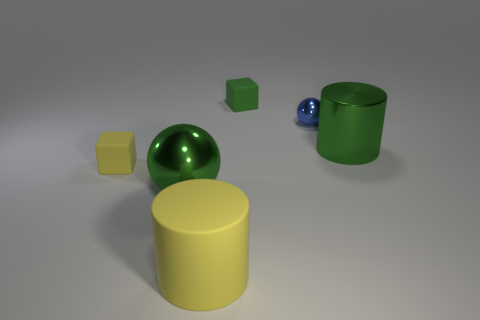Subtract all green balls. How many balls are left? 1 Add 3 big brown metallic cubes. How many objects exist? 9 Subtract all spheres. How many objects are left? 4 Add 1 yellow shiny blocks. How many yellow shiny blocks exist? 1 Subtract 0 purple cylinders. How many objects are left? 6 Subtract 1 spheres. How many spheres are left? 1 Subtract all blue balls. Subtract all yellow cylinders. How many balls are left? 1 Subtract all purple blocks. How many blue spheres are left? 1 Subtract all metal things. Subtract all rubber objects. How many objects are left? 0 Add 3 large shiny spheres. How many large shiny spheres are left? 4 